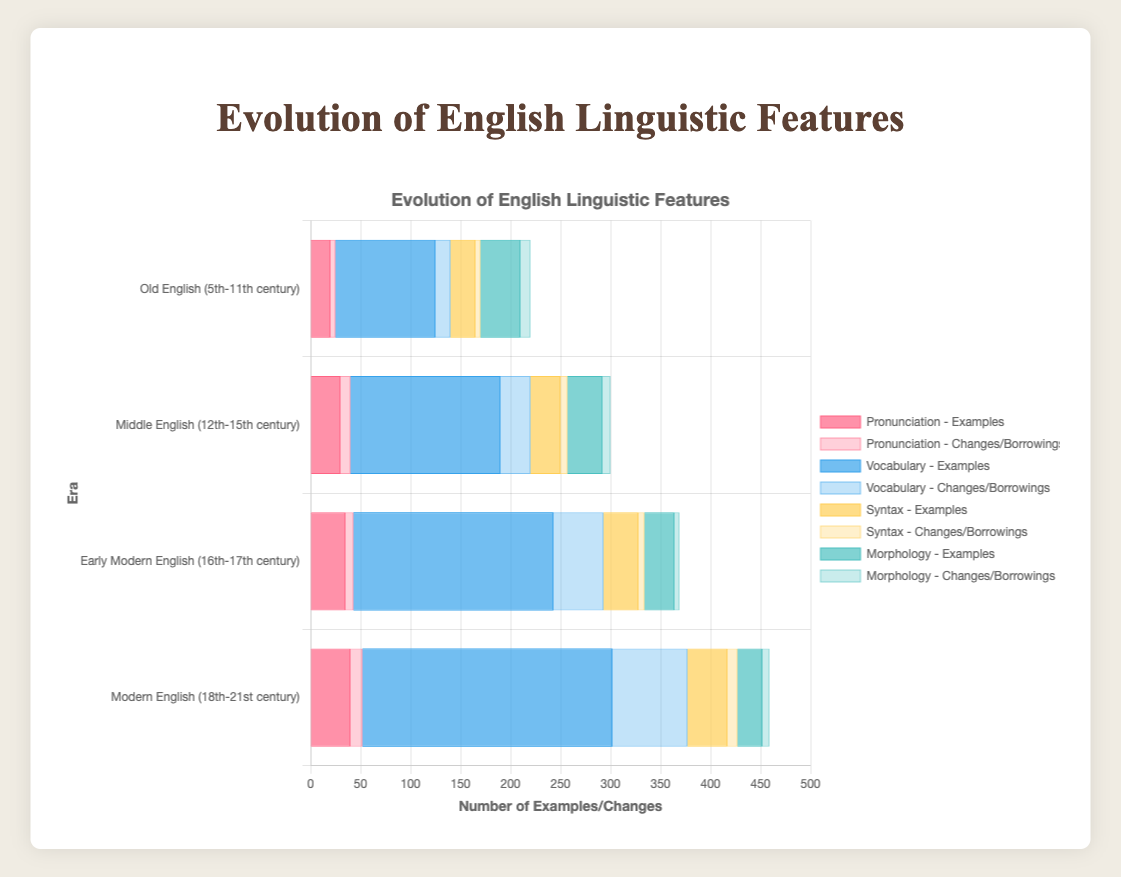What era saw the highest number of examples for the Vocabulary feature? The Vocabulary feature data shows the highest bar for examples during the Modern English era (18th-21st century) with 250 examples.
Answer: Modern English (18th-21st century) Which feature had the most changes/borrowings during the Early Modern English era? For Early Modern English (16th-17th century), the feature with the highest number of changes/borrowings is Vocabulary with 50 borrowings.
Answer: Vocabulary How did the number of examples for Syntax change from Old English to Modern English? Syntax examples increased from 25 in Old English (5th-11th century) to 40 in Modern English (18th-21st century), showing a gradual increase.
Answer: Increased by 15 Which era experienced the largest increase in borrowings for the Vocabulary feature compared to the previous era? From Middle English (12th-15th century) to Early Modern English (16th-17th century), borrowings increased by 20 (from 30 to 50).
Answer: Early Modern English (16th-17th century) How do the changes in Pronunciation compare between Middle English and Modern English? Modern English (18th-21st century) had 12 changes in pronunciation, while Middle English (12th-15th century) had 10 changes, indicating Modern English had 2 more changes.
Answer: Modern English had 2 more Which era shows the least examples for Pronunciation, and what could be a plausible visual explanation for this observation? Old English (5th-11th century) shows the least examples for Pronunciation with 20 examples. Visually, the bar for Old English is the shortest in the Pronunciation category.
Answer: Old English (5th-11th century) Calculate the average number of borrowings for the Vocabulary feature across all eras. Add the number of borrowings across all eras (15 + 30 + 50 + 75) to get 170, then divide by 4 (the number of eras): 170/4 = 42.5.
Answer: 42.5 Comparing Morphology, what is the total number of changes across all eras, and how does it compare to the Syntax feature's total changes across all eras? For Morphology, the total changes are 10 + 8 + 5 + 7 = 30. For Syntax, the total changes are 5 + 7 + 6 + 10 = 28. Morphology has 2 more changes in total compared to Syntax.
Answer: Morphology has 2 more changes Identify the era and feature with the highest number of both examples and changes/borrowings combined. The Modern English era (18th-21st century) Vocabulary feature has the highest combined total with 250 examples + 75 borrowings = 325.
Answer: Modern English Vocabulary In the Middle English era, what is the difference between changes in Syntax and Morphology? In Middle English, Syntax has 7 changes, and Morphology has 8 changes, resulting in a difference of 1 change (8 - 7).
Answer: 1 change 